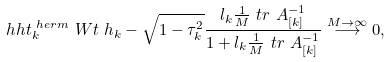<formula> <loc_0><loc_0><loc_500><loc_500>& \ h h t _ { k } ^ { \ h e r m } \ W t \ h _ { k } - \sqrt { 1 - \tau _ { k } ^ { 2 } } \frac { l _ { k } \frac { 1 } { M } \ t r \ A _ { [ k ] } ^ { - 1 } } { 1 + l _ { k } \frac { 1 } { M } \ t r \ A _ { [ k ] } ^ { - 1 } } \overset { M \to \infty } { \longrightarrow } 0 ,</formula> 